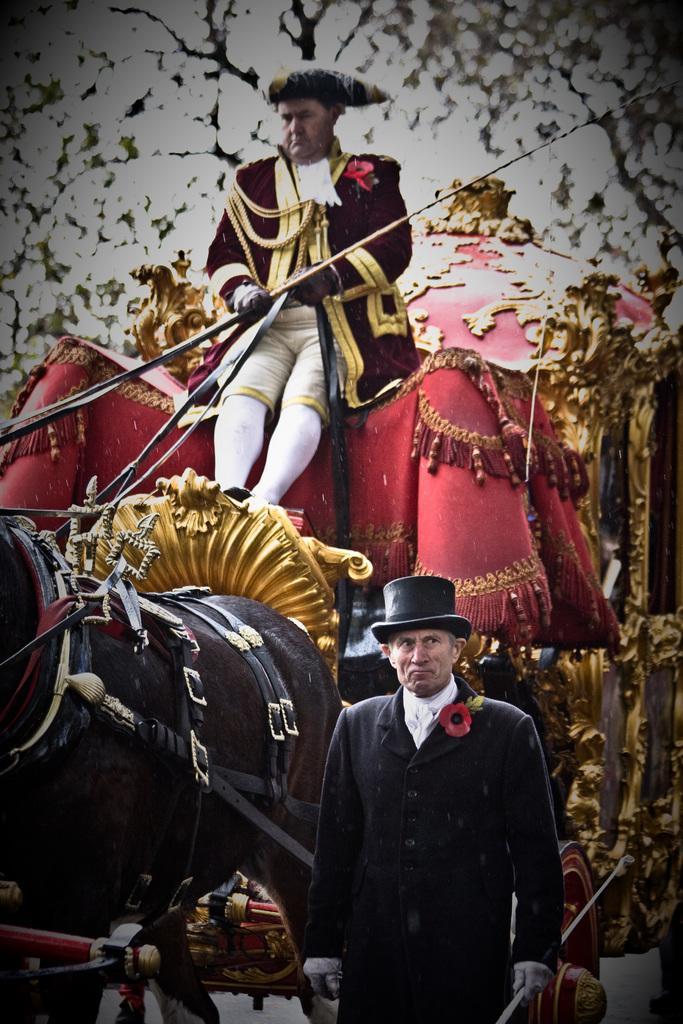In one or two sentences, can you explain what this image depicts? A man is sitting in the horse cart in the middle in the down a man is standing He wear a hat. 